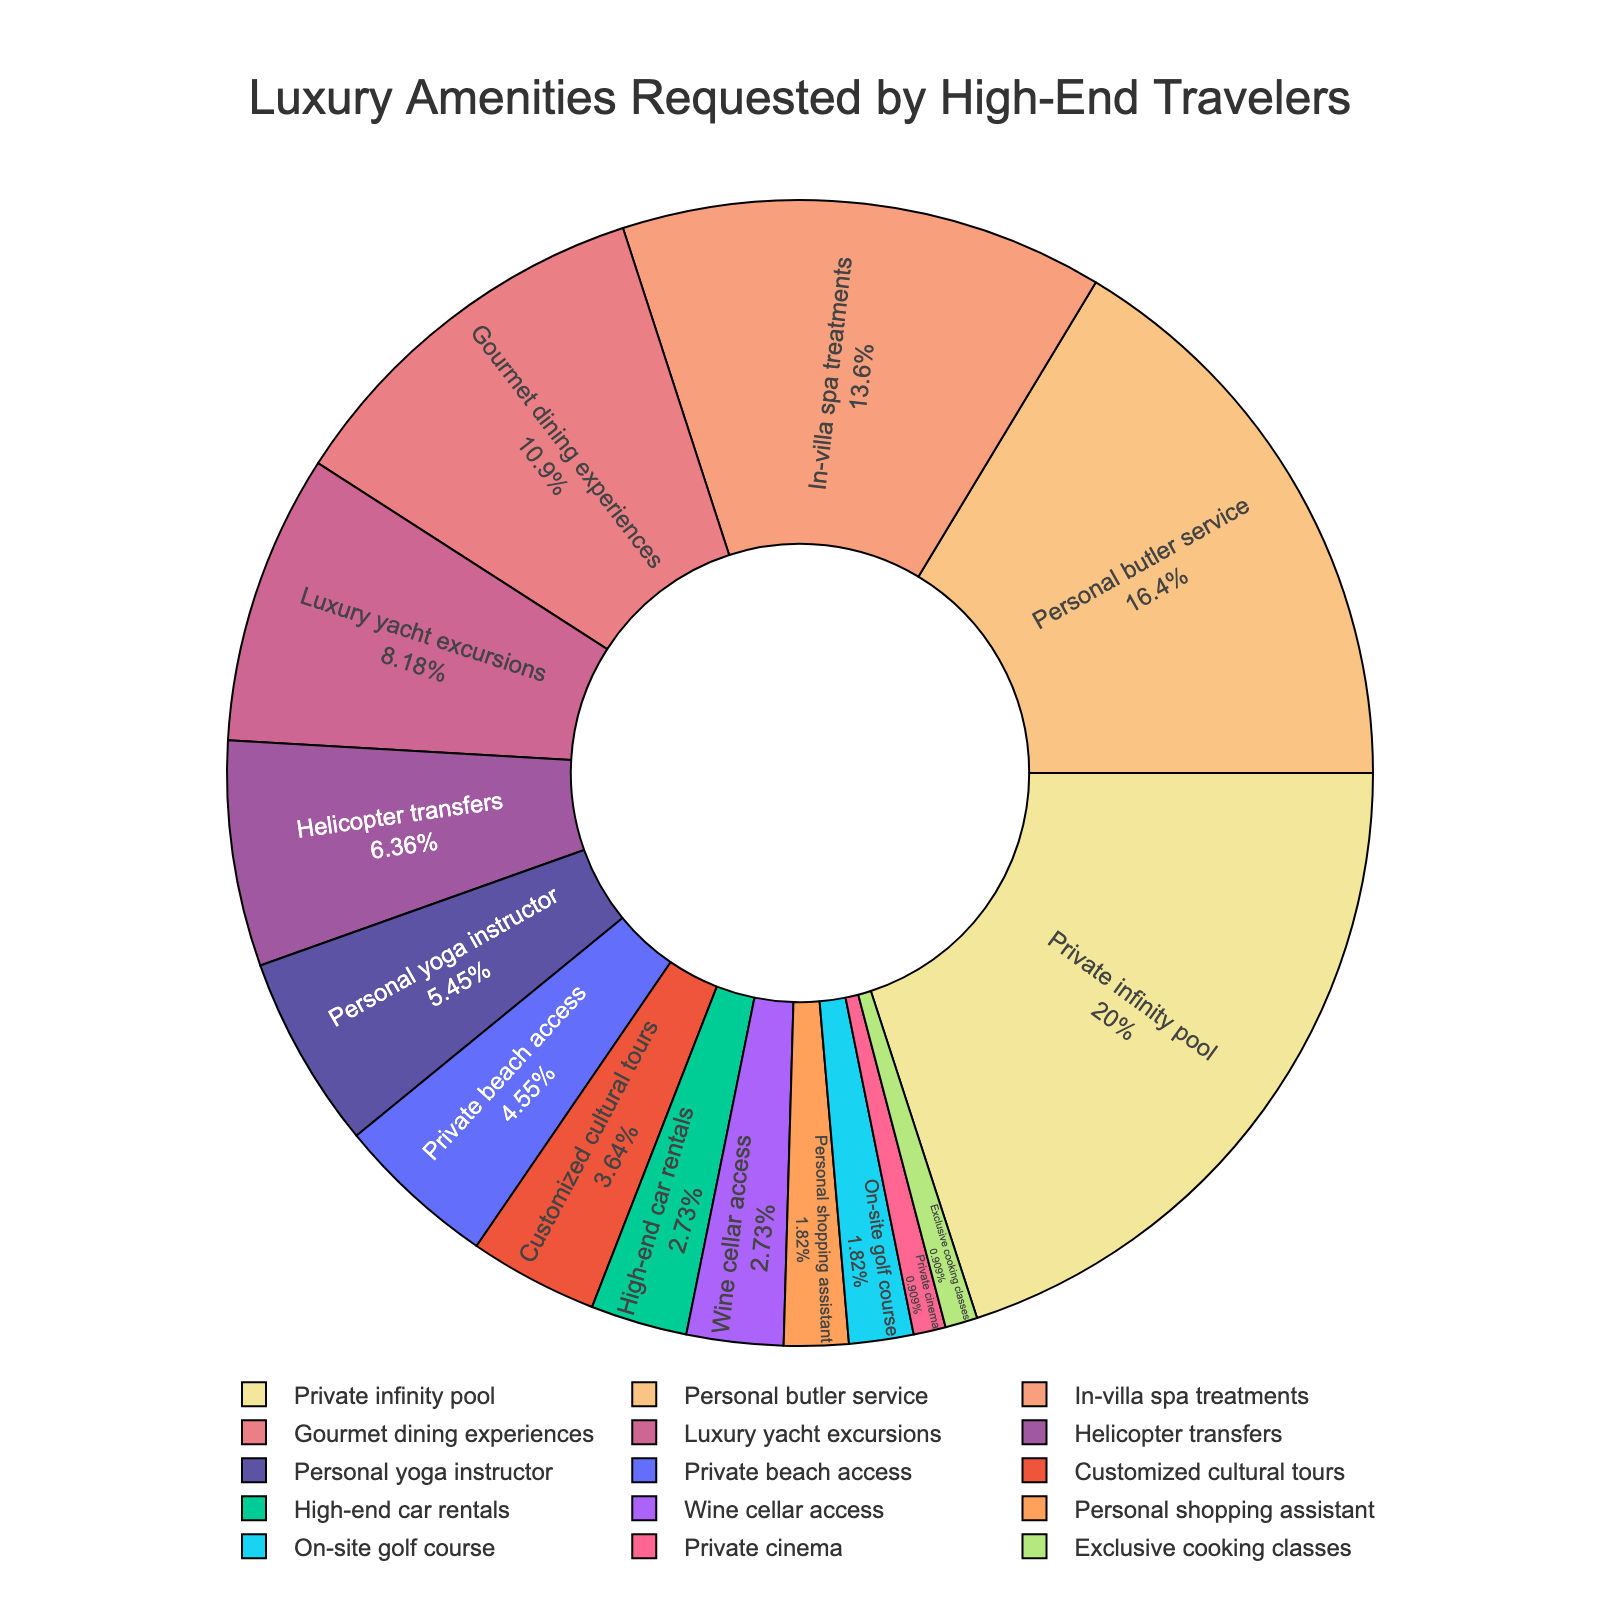What's the most requested luxury amenity by high-end travelers? The largest section of the pie chart represents the most requested amenity. The section labeled "Private infinity pool" is the largest.
Answer: Private infinity pool Which amenities constitute more than half of the total requests combined? By summing the percentages in descending order until the total exceeds 50%, we get: Private infinity pool (22%) + Personal butler service (18%) + In-villa spa treatments (15%), which sums to 55%.
Answer: Private infinity pool, Personal butler service, In-villa spa treatments How many amenities are requested by at least 5% of high-end travelers? Count the segments with percentages equal to or greater than 5%. The segments are: Private infinity pool (22%), Personal butler service (18%), In-villa spa treatments (15%), Gourmet dining experiences (12%), Luxury yacht excursions (9%), Helicopter transfers (7%), and Personal yoga instructor (6%).
Answer: 7 Which luxury amenities are requested by fewer than 3% of high-end travelers? Identify the segments with percentages less than 3%. These segments are: Personal shopping assistant (2%), On-site golf course (2%), Private cinema (1%), and Exclusive cooking classes (1%).
Answer: Personal shopping assistant, On-site golf course, Private cinema, Exclusive cooking classes How does the percentage of travelers requesting Gourmet dining experiences compare to those requesting Luxury yacht excursions? Compare the percentage values of the two amenities: Gourmet dining experiences (12%) and Luxury yacht excursions (9%). 12% is greater than 9%.
Answer: Gourmet dining experiences is higher What is the combined percentage of requests for Private beach access and Customized cultural tours? Add the percentages of Private beach access (5%) and Customized cultural tours (4%). 5% + 4% = 9%.
Answer: 9% Which amenity has a percentage exactly double that of Personal yoga instructor? The percentage for Personal yoga instructor is 6%. Double this is 12%. Referring to the chart, Gourmet dining experiences has a percentage of 12%.
Answer: Gourmet dining experiences How much more popular is Helicopter transfers than Personal shopping assistant? Subtract the percentage of Personal shopping assistant (2%) from the percentage of Helicopter transfers (7%). 7% - 2% = 5%.
Answer: 5% What is the percentage difference between Personal butler service and In-villa spa treatments? Subtract the percentage of In-villa spa treatments (15%) from the percentage of Personal butler service (18%). 18% - 15% = 3%.
Answer: 3% What fraction of the pie chart is represented by the four least requested amenities? Identify the four least requested amenities: Private cinema (1%), Exclusive cooking classes (1%), Personal shopping assistant (2%), and On-site golf course (2%). Add these percentages: 1% + 1% + 2% + 2% = 6%. 6% of 100% gives a fraction of 6/100 or 3/50.
Answer: 3/50 